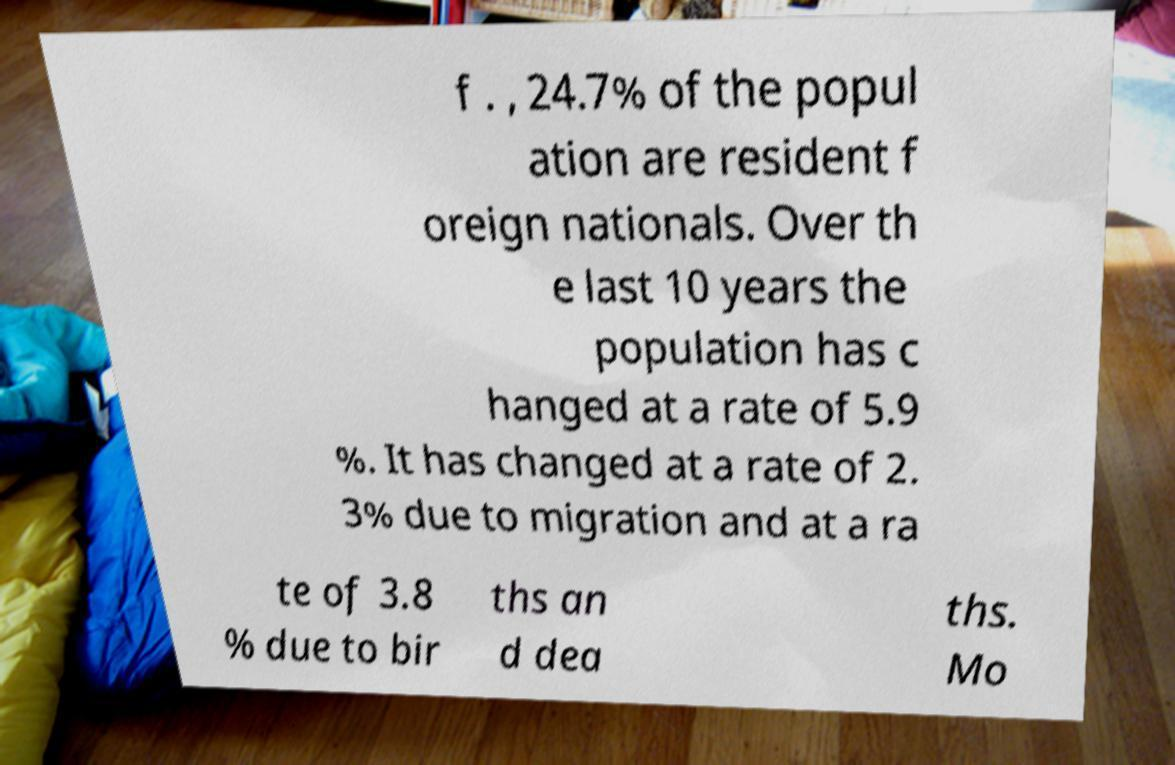Please identify and transcribe the text found in this image. f . , 24.7% of the popul ation are resident f oreign nationals. Over th e last 10 years the population has c hanged at a rate of 5.9 %. It has changed at a rate of 2. 3% due to migration and at a ra te of 3.8 % due to bir ths an d dea ths. Mo 